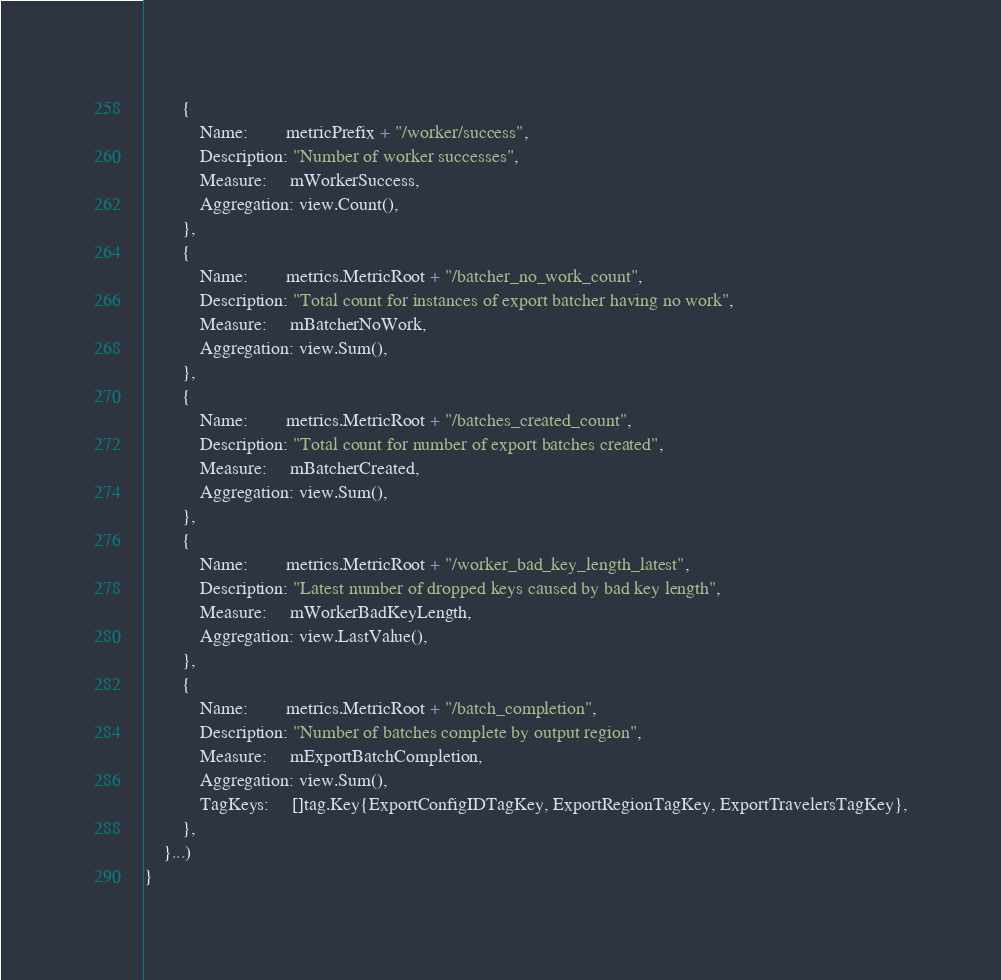Convert code to text. <code><loc_0><loc_0><loc_500><loc_500><_Go_>		{
			Name:        metricPrefix + "/worker/success",
			Description: "Number of worker successes",
			Measure:     mWorkerSuccess,
			Aggregation: view.Count(),
		},
		{
			Name:        metrics.MetricRoot + "/batcher_no_work_count",
			Description: "Total count for instances of export batcher having no work",
			Measure:     mBatcherNoWork,
			Aggregation: view.Sum(),
		},
		{
			Name:        metrics.MetricRoot + "/batches_created_count",
			Description: "Total count for number of export batches created",
			Measure:     mBatcherCreated,
			Aggregation: view.Sum(),
		},
		{
			Name:        metrics.MetricRoot + "/worker_bad_key_length_latest",
			Description: "Latest number of dropped keys caused by bad key length",
			Measure:     mWorkerBadKeyLength,
			Aggregation: view.LastValue(),
		},
		{
			Name:        metrics.MetricRoot + "/batch_completion",
			Description: "Number of batches complete by output region",
			Measure:     mExportBatchCompletion,
			Aggregation: view.Sum(),
			TagKeys:     []tag.Key{ExportConfigIDTagKey, ExportRegionTagKey, ExportTravelersTagKey},
		},
	}...)
}
</code> 